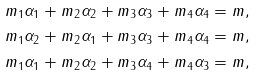Convert formula to latex. <formula><loc_0><loc_0><loc_500><loc_500>& m _ { 1 } \alpha _ { 1 } + m _ { 2 } \alpha _ { 2 } + m _ { 3 } \alpha _ { 3 } + m _ { 4 } \alpha _ { 4 } = m , \\ & m _ { 1 } \alpha _ { 2 } + m _ { 2 } \alpha _ { 1 } + m _ { 3 } \alpha _ { 3 } + m _ { 4 } \alpha _ { 4 } = m , \\ & m _ { 1 } \alpha _ { 1 } + m _ { 2 } \alpha _ { 2 } + m _ { 3 } \alpha _ { 4 } + m _ { 4 } \alpha _ { 3 } = m ,</formula> 